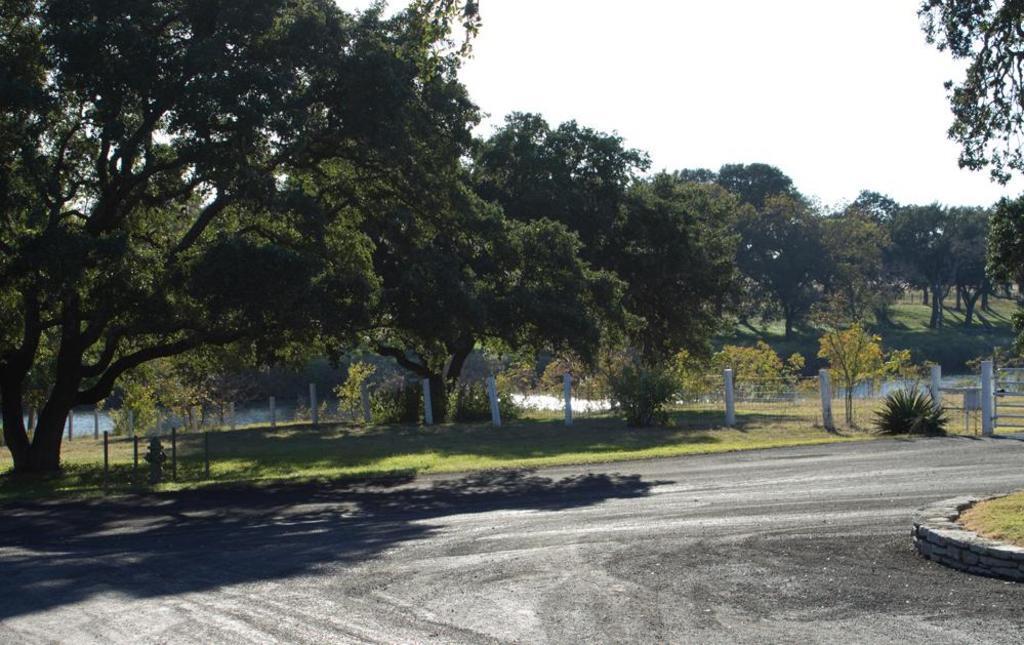Could you give a brief overview of what you see in this image? In this image in the center there is grass on the ground and there are trees. There are plants and there is a fire hydrant and there is a fence. On the right side there's grass on the ground and on the top right there are leaves. 